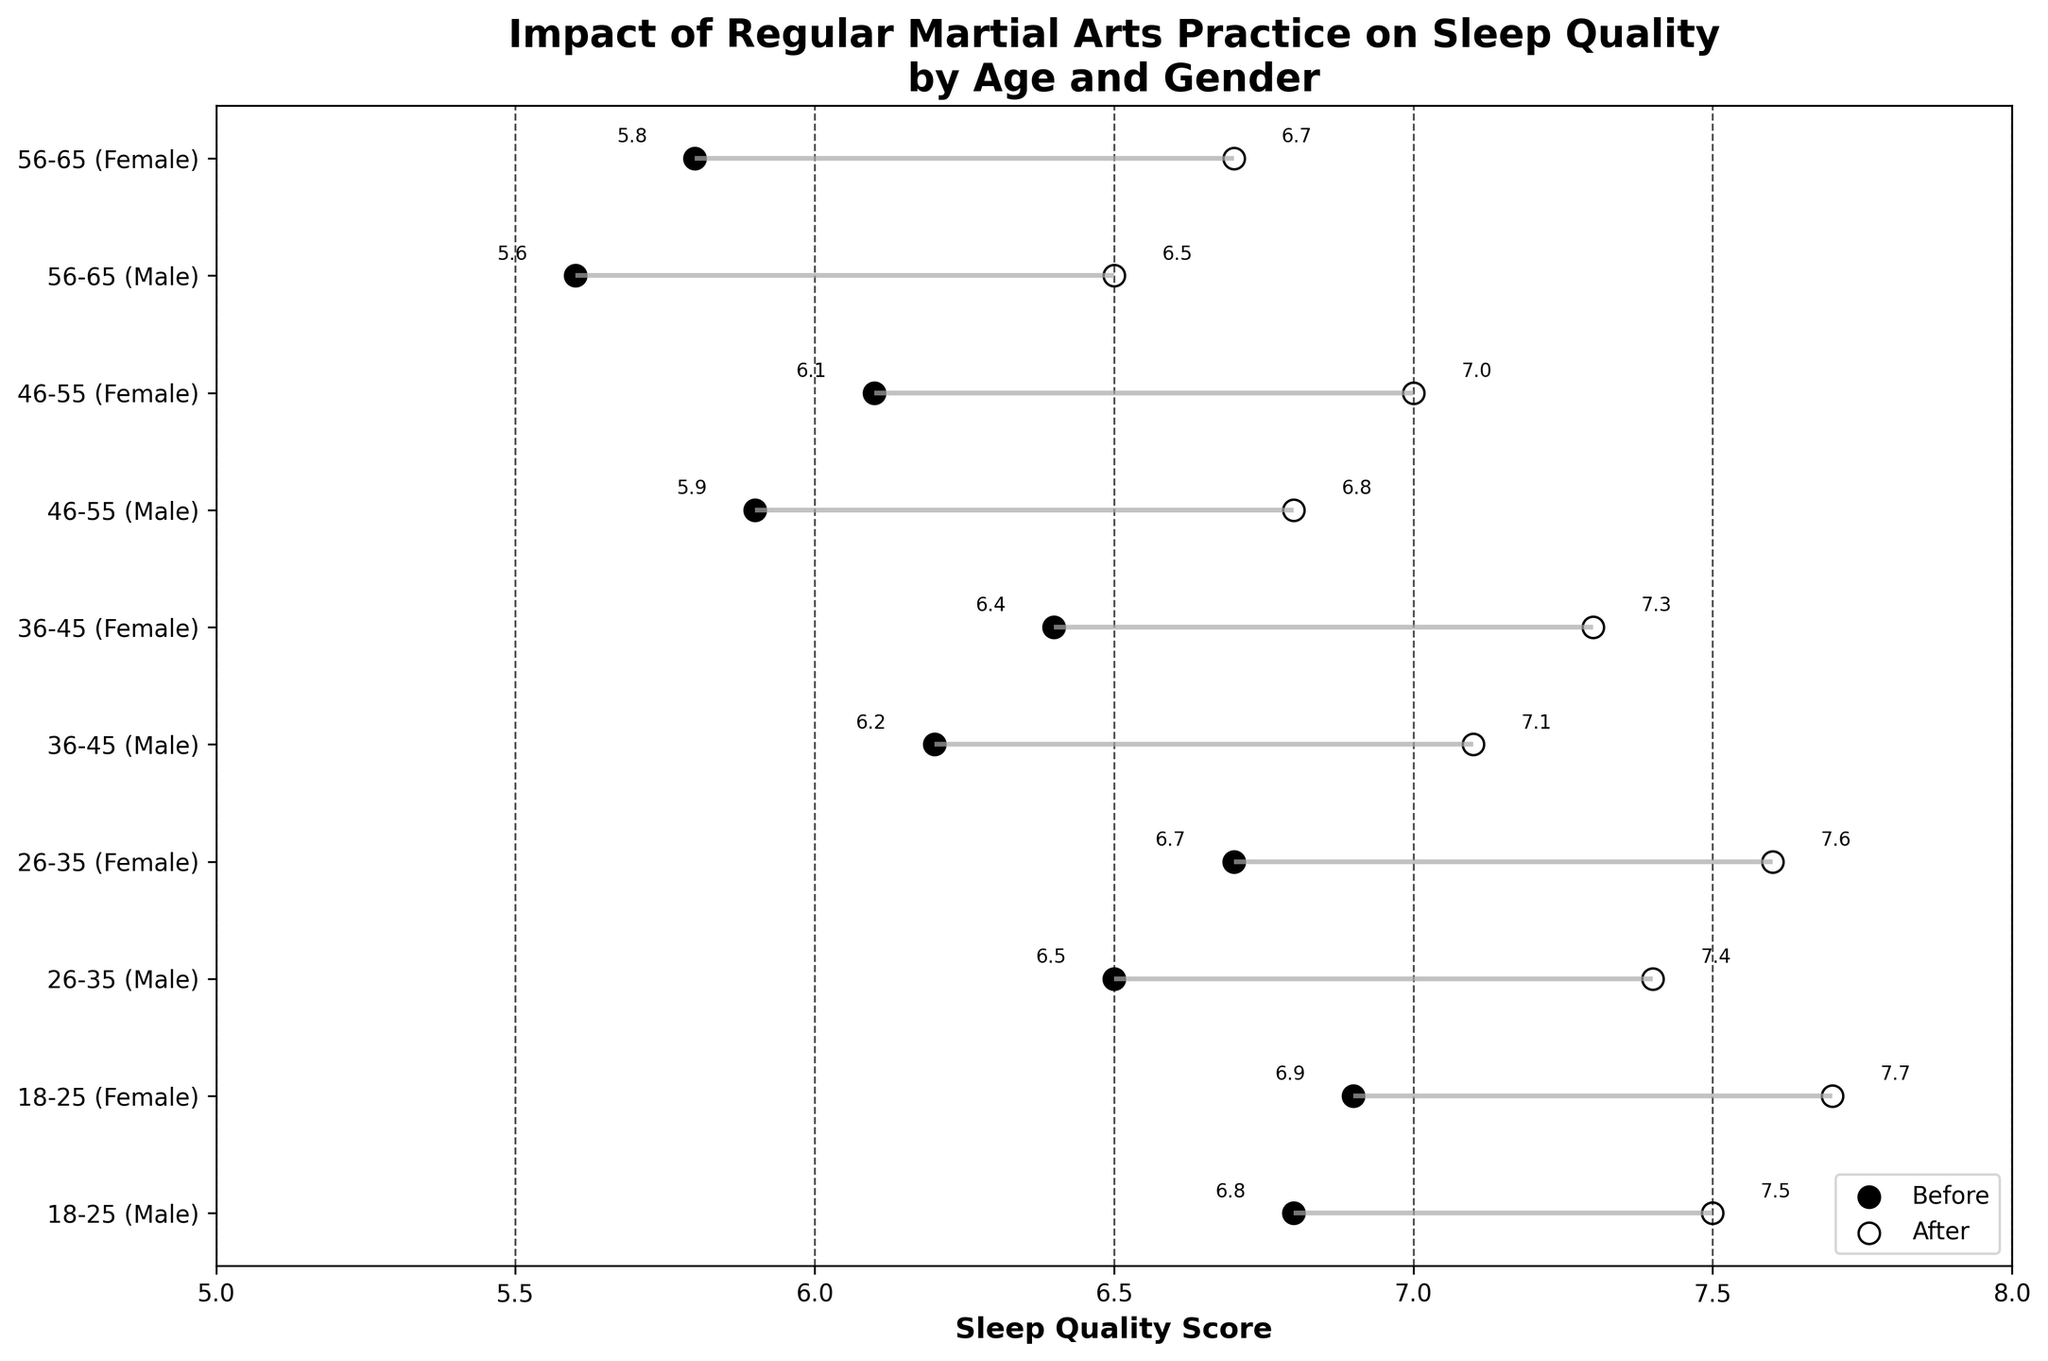What is the title of the plot? The title of the plot is typically displayed at the top of the figure. In this case, the title is "Impact of Regular Martial Arts Practice on Sleep Quality by Age and Gender".
Answer: Impact of Regular Martial Arts Practice on Sleep Quality by Age and Gender Which age group shows the highest improvement in sleep quality scores? To find the highest improvement, calculate the difference between the 'After' and 'Before' values for each age group and identify the largest difference. For 18-25 (Male) it is 0.7, for 18-25 (Female) 0.8, for 26-35 (Male) 0.9, for 26-35 (Female) 0.9, for 36-45 (Male) 0.9, for 36-45 (Female) 0.9, for 46-55 (Male) 0.9, for 46-55 (Female) 0.9, for 56-65 (Male) 0.9, for 56-65 (Female) 0.9. They all show an improvement of 0.9.
Answer: 26-35, 36-45, 46-55, 56-65 (Male and Female) What is the maximum sleep quality score achieved after martial arts practice? Find the highest value in the 'After_Martial_Arts' column. From the data, the maximum is 7.7 for 18-25 (Female).
Answer: 7.7 Does any age group have the same sleep quality score before martial arts practice? Compare the 'Before_Martial_Arts' values for all age groups. There are no duplicate values.
Answer: No Which gender shows a greater improvement in sleep quality score in the 56-65 age group? Calculate the difference for both genders. For 56-65 (Male), it's 6.5 - 5.6 = 0.9; for 56-65 (Female), it's 6.7 - 5.8 = 0.9. Both genders show the same improvement.
Answer: Equal By how many points on average does sleep quality improve for females after martial arts practice? To find the average improvement, sum the improvements for all female age groups and divide by the number of groups: (7.7-6.9 + 7.6-6.7 + 7.3-6.4 + 7.0-6.1 + 6.7-5.8) / 5 = 0.8 + 0.9 + 0.9 + 0.9 + 0.9 = 4.4 / 5 = 0.88.
Answer: 0.88 What is the sleep quality score for 46-55 (Female) before and after martial arts practice? Refer to the specific data points for the age group 46-55 (Female). The 'Before' value is 6.1, and the 'After' value is 7.0.
Answer: 6.1, 7.0 Is there any age group where males and females have the same 'After' sleep quality score? Review the 'After_Martial_Arts' values for each age group by gender. None of the age groups have exactly matching 'After' values for both genders.
Answer: No In which age group is the average 'Before' sleep quality the lowest? Calculate the average 'Before' score for each age group: (6.8+6.9)/2 for 18-25, (6.5+6.7)/2 for 26-35, (6.2+6.4)/2 for 36-45, (5.9+6.1)/2 for 46-55, (5.6+5.8)/2 for 56-65. The lowest average is in the 56-65 group at (5.6+5.8)/2 = 5.7.
Answer: 56-65 